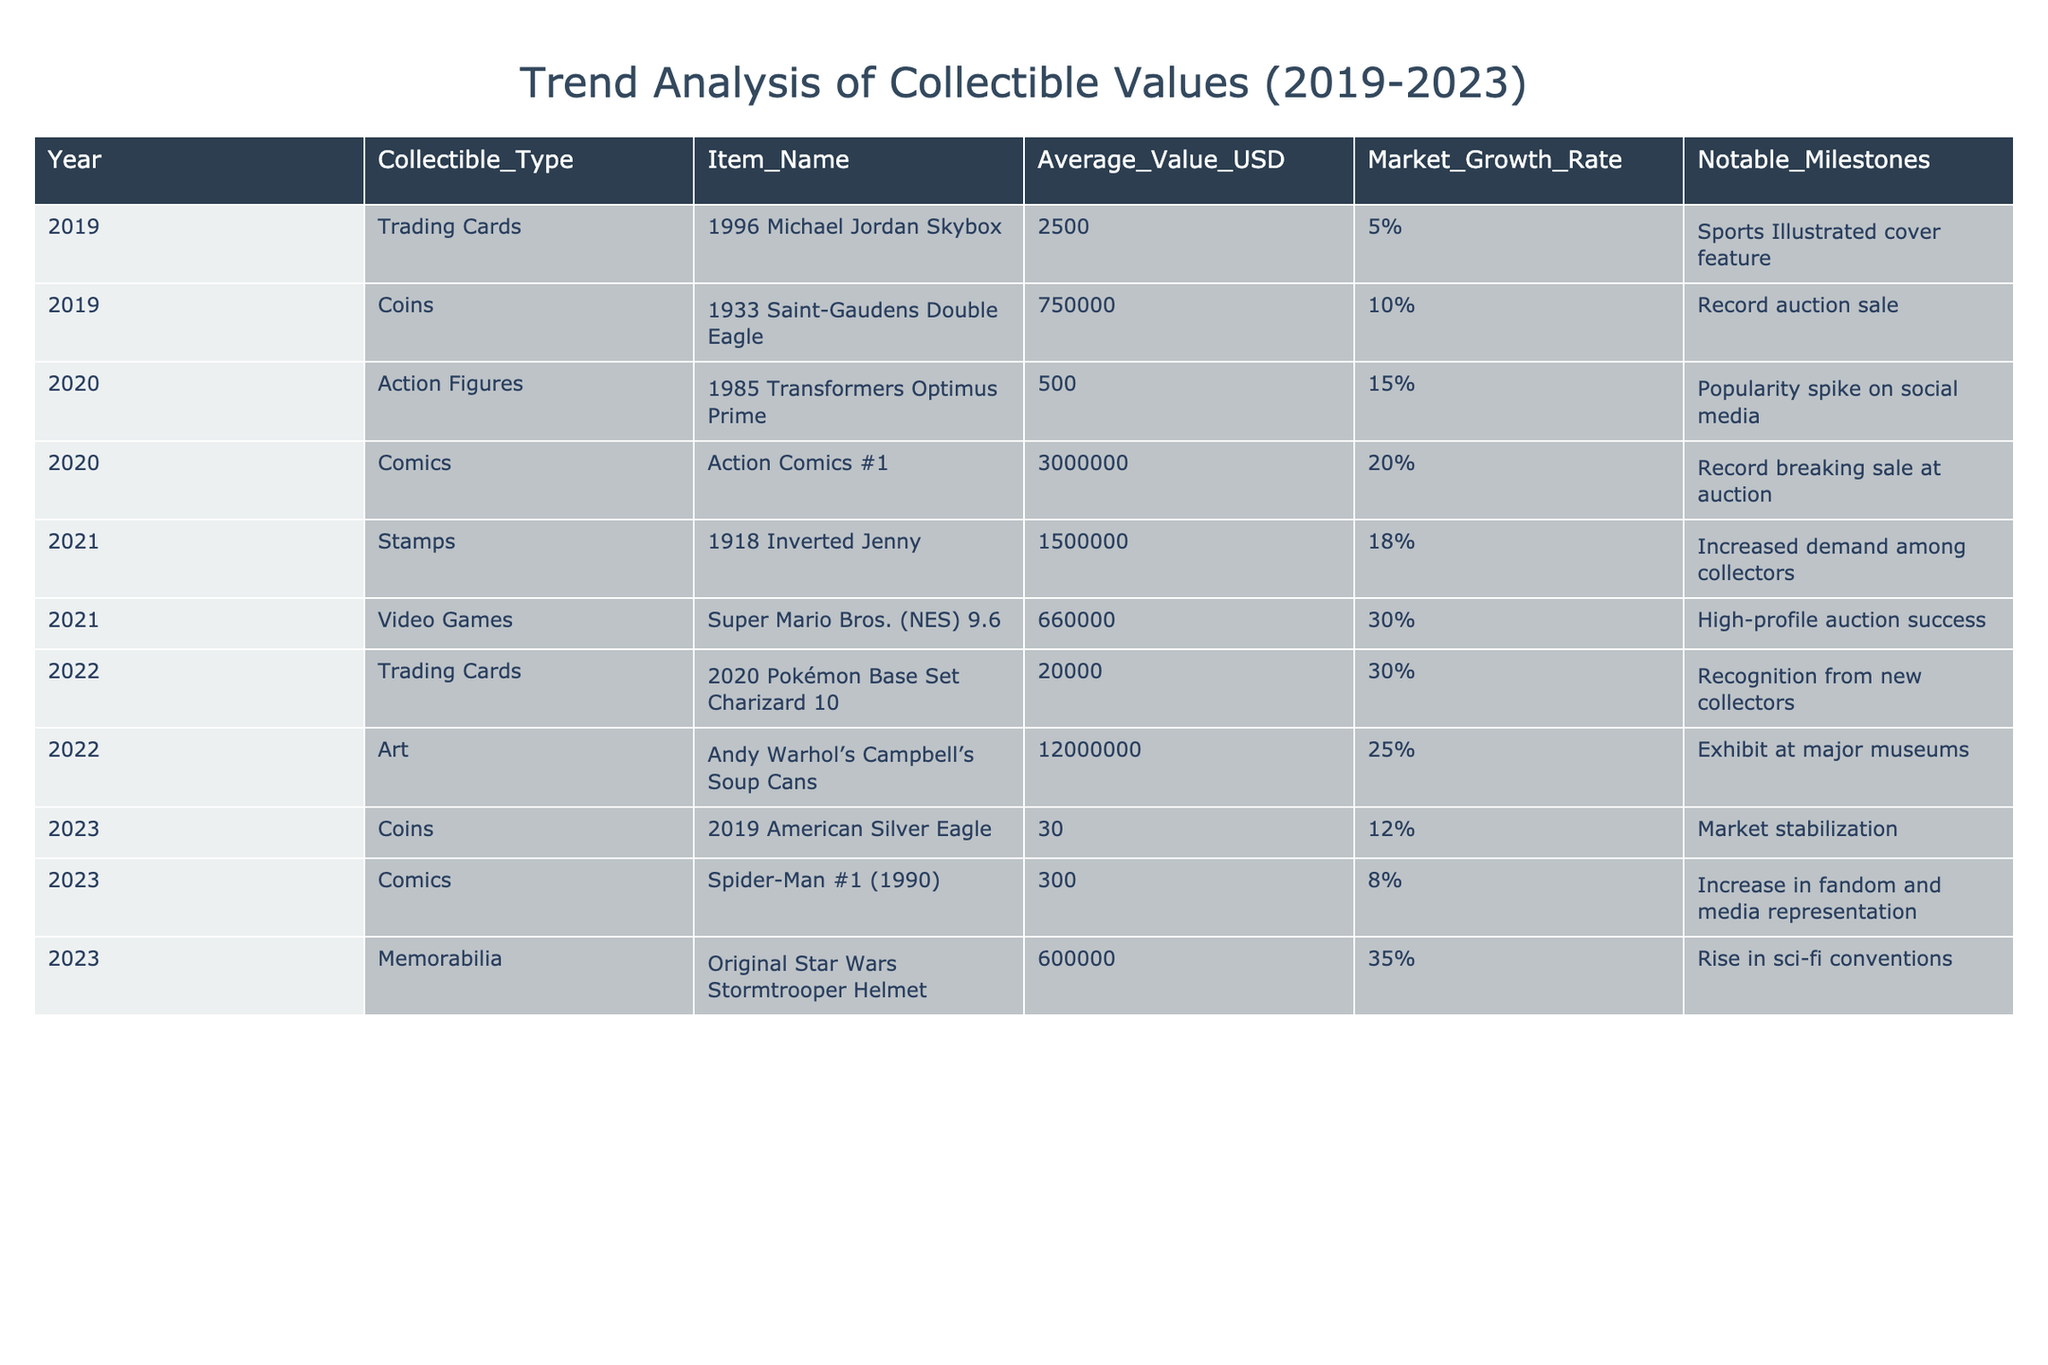What is the average value of the collectibles in 2023? The values for collectibles in 2023 are: 30, 300, and 600,000. Add these values: 30 + 300 + 600,000 = 600,330. There are three entries, so divide by 3 to get the average: 600,330 / 3 = 200,110.
Answer: 200,110 Which collectible saw the highest average value in 2021? In 2021, there are two collectibles listed: the stamp, which has an average value of 1,500,000, and the video game at 660,000. Comparing these values, 1,500,000 is higher than 660,000. Thus, the stamp is the highest.
Answer: 1,500,000 Did the average value of action figures increase from 2020 to 2022? The average value of action figures in 2020 is 500 and in 2022, it is 20,000. Since 20,000 is greater than 500, it shows an increase in value.
Answer: Yes What is the market growth rate of trading cards in 2022? The data shows that the market growth rate for trading cards in 2022 is 30%, as stated in the relevant row in the table.
Answer: 30% Which collectible experienced a notable milestone related to sports media? The 1996 Michael Jordan Skybox trading card saw the notable milestone of being featured on the Sports Illustrated cover, as noted in the 2019 entry.
Answer: 1996 Michael Jordan Skybox Which collectible type had the most significant increase in market growth rate from 2020 to 2021? The growth rates for collectibles in 2020 and 2021 were as follows: action figures (15% in 2020) and video games (30% in 2021). Therefore, the increase from 15% to 30% shows a change of 15%, indicating significant growth in the video games category.
Answer: Video Games What was the notable milestone for coins in 2023? The table indicates that the notable milestone for the 2019 American Silver Eagle was market stabilization, noted in 2023 under the coins row.
Answer: Market stabilization Which of the collectibles listed had a market growth rate below 10% in 2023? In 2023, the collectibles listed include coins at 12% and comics at 8%. The comic item is the only one with a market growth rate below 10%, as 8% is less than 10%.
Answer: Spider-Man #1 (1990) 